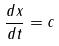<formula> <loc_0><loc_0><loc_500><loc_500>\frac { d x } { d t } = c</formula> 